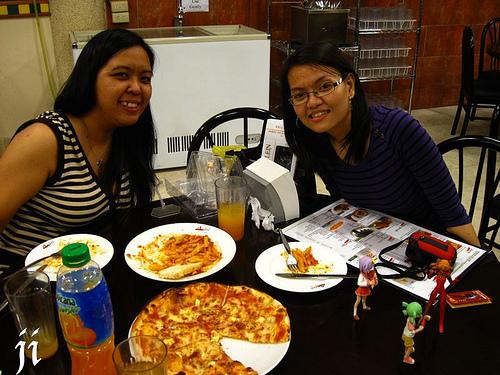Why are they smiling?
Answer briefly. Happy. What type of pizza is this?
Write a very short answer. Cheese. Is the food in a bowl?
Concise answer only. No. How full is the water bottle?
Quick response, please. Half. How many plates are in this image?
Short answer required. 4. Is this food prepared for a special occasion?
Keep it brief. No. What is under the fork?
Answer briefly. Pizza. How many pizzas are pictured?
Keep it brief. 1. Is this pizza vegetable heavy?
Concise answer only. No. Is it likely that the girls have blue eyes?
Keep it brief. No. Are the people in this photo totally sober?
Be succinct. Yes. Has the pizza been in the oven yet?
Answer briefly. Yes. Is there a salt shaker on the table?
Concise answer only. No. Is this an indoor table?
Answer briefly. Yes. What is in the bottles?
Quick response, please. Juice. Why is the woman in the striped shirt smiling?
Write a very short answer. Happy. Does beer go well with this food?
Answer briefly. Yes. Do the women have anime figures?
Give a very brief answer. Yes. 